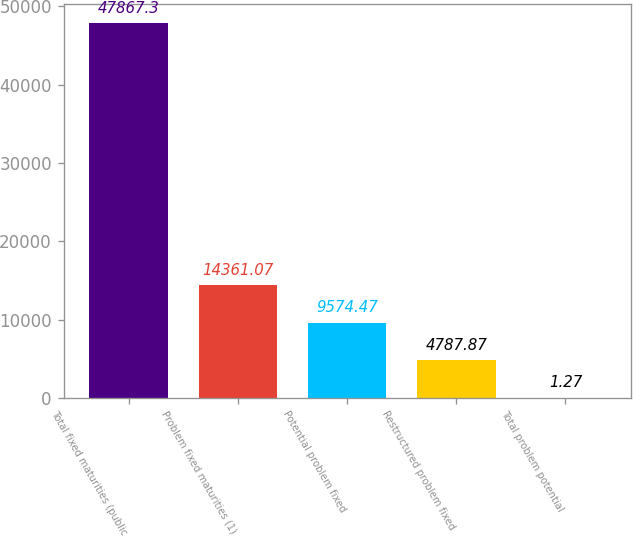<chart> <loc_0><loc_0><loc_500><loc_500><bar_chart><fcel>Total fixed maturities (public<fcel>Problem fixed maturities (1)<fcel>Potential problem fixed<fcel>Restructured problem fixed<fcel>Total problem potential<nl><fcel>47867.3<fcel>14361.1<fcel>9574.47<fcel>4787.87<fcel>1.27<nl></chart> 